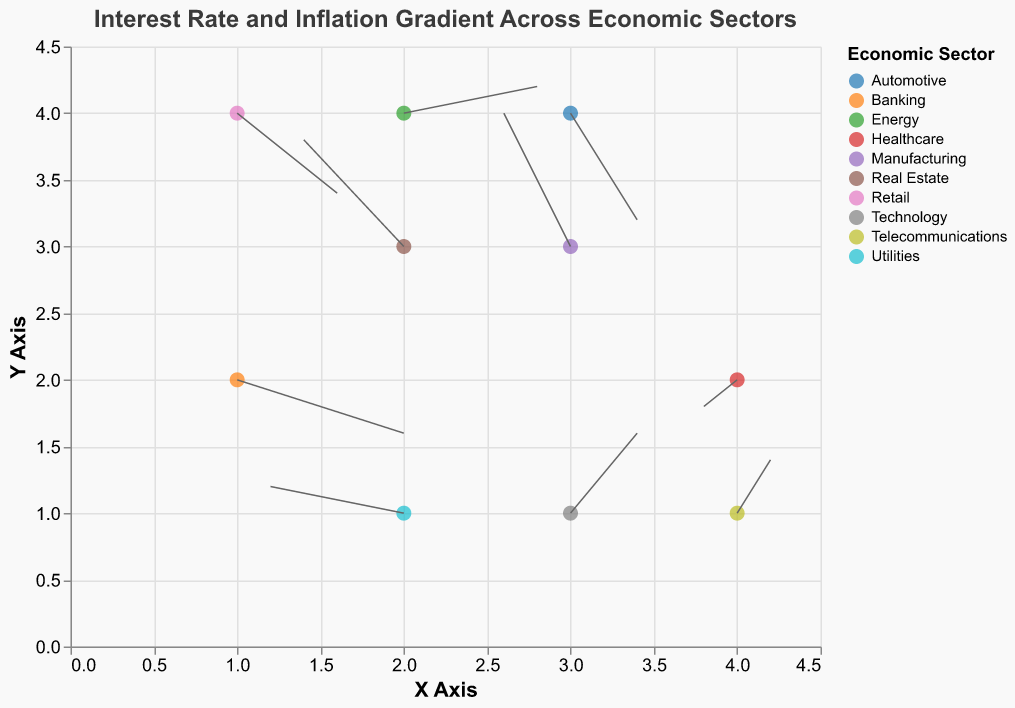What is the title of the plot? The title of the plot is displayed at the top and reads "Interest Rate and Inflation Gradient Across Economic Sectors".
Answer: Interest Rate and Inflation Gradient Across Economic Sectors How many economic sectors are represented in the plot? The legend on the right side indicates the distinct sectors by different colors. Count the number of unique colors and sector names.
Answer: 10 Which sector has the highest positive gradient in interest rates (u)? Observe the vectors' horizontal components (u) and find the largest value. The Banking sector has a u value of 0.05, which is the highest.
Answer: Banking Which sectors indicate a negative inflation gradient (v)? Check the vertical components of the vectors (v) and identify those with negative values. Banking, Retail, and Automotive have negative v values.
Answer: Banking, Retail, Automotive What are the x and y coordinates for the Technology sector? Find the point labeled Technology and note the x and y coordinates from the tooltip.
Answer: (3, 1) Which sector has the smallest vector magnitude? Calculate the magnitude by \(\sqrt{u^2 + v^2}\) for each sector. The Healthcare sector has the smallest vector with u = -0.01, v = -0.01, leading to a magnitude of \(\sqrt{0.01^2 + 0.01^2} = \sqrt{0.0001 + 0.0001} = \sqrt{0.0002} \approx 0.014\).
Answer: Healthcare Compare the gradients in the Manufacturing and Real Estate sectors. Which sector has a higher inflation gradient (v)? Look at the vertical components (v) for Manufacturing and Real Estate. Manufacturing has v = 0.05, and Real Estate has v = 0.04.
Answer: Manufacturing Which sector shows a decrease in both interest rates and inflation? Identify the sectors with both u and v as negative values. The Healthcare sector fits this criterion with u = -0.01 and v = -0.01.
Answer: Healthcare What is the combined vector sum of the gradients for sectors Banking and Energy? Add the u and v components separately for Banking (u = 0.05, v = -0.02) and Energy (u = 0.04, v = 0.01). The combined u: 0.05 + 0.04 = 0.09 and combined v: -0.02 + 0.01 = -0.01.
Answer: u = 0.09, v = -0.01 